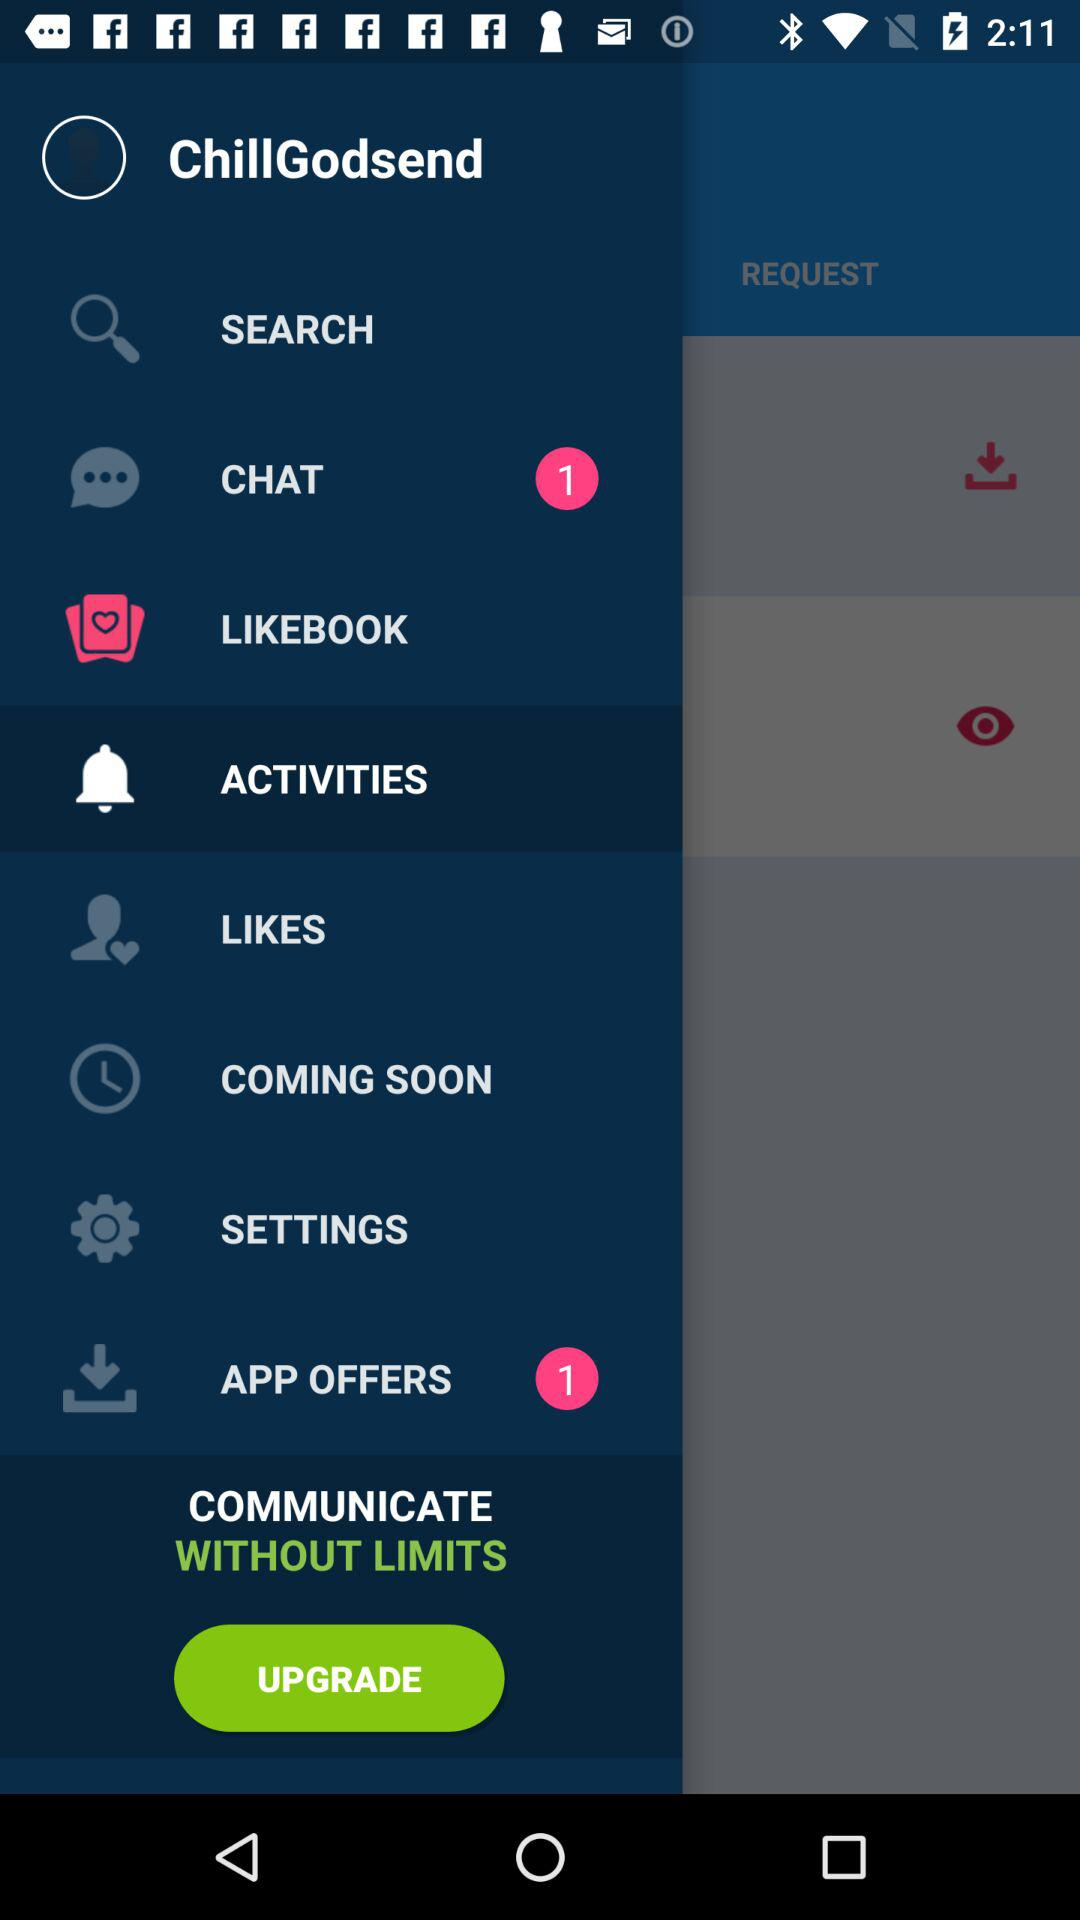Which item is selected? The selected item is "ACTIVITIES". 